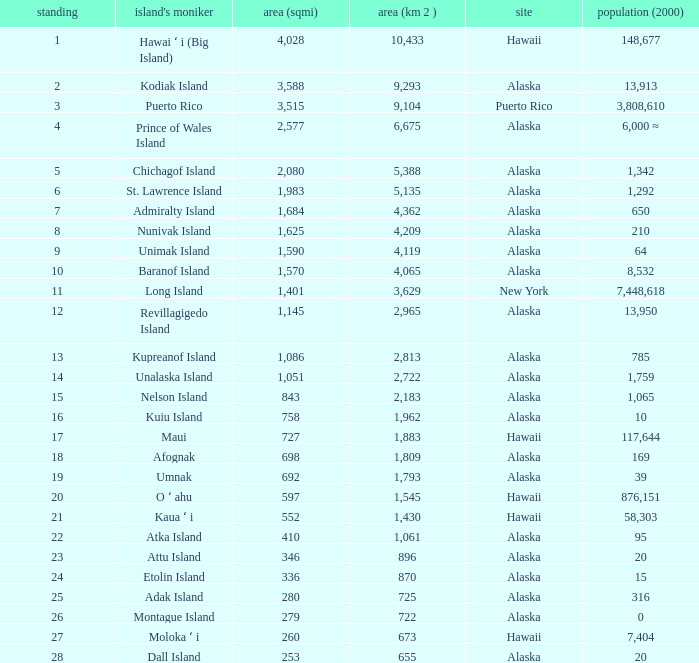What is the highest rank for Nelson Island with area more than 2,183? None. 